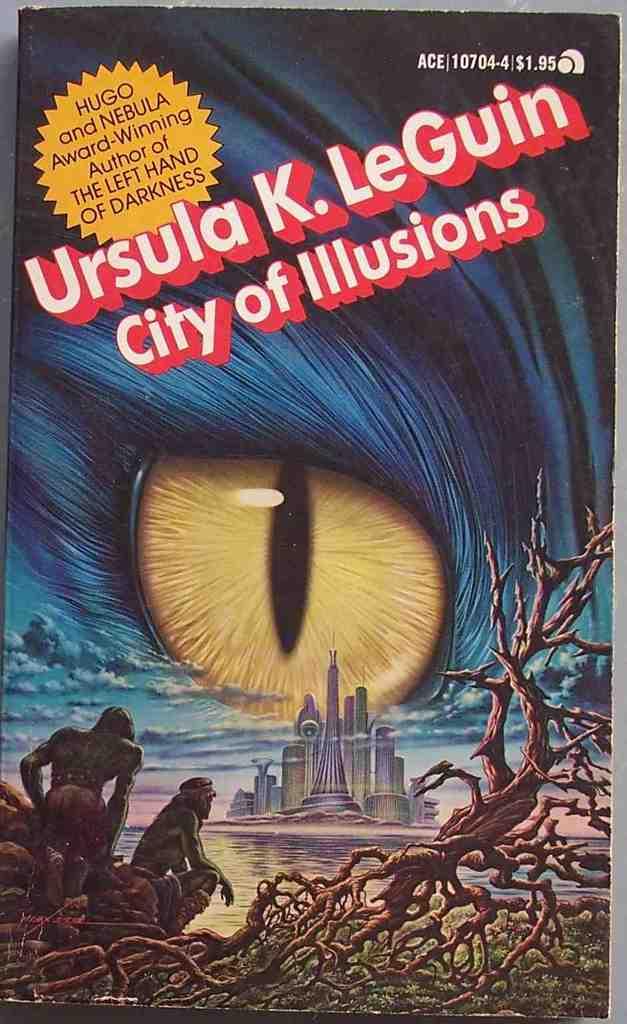Whats the name of the book?
Make the answer very short. City of illusions. 